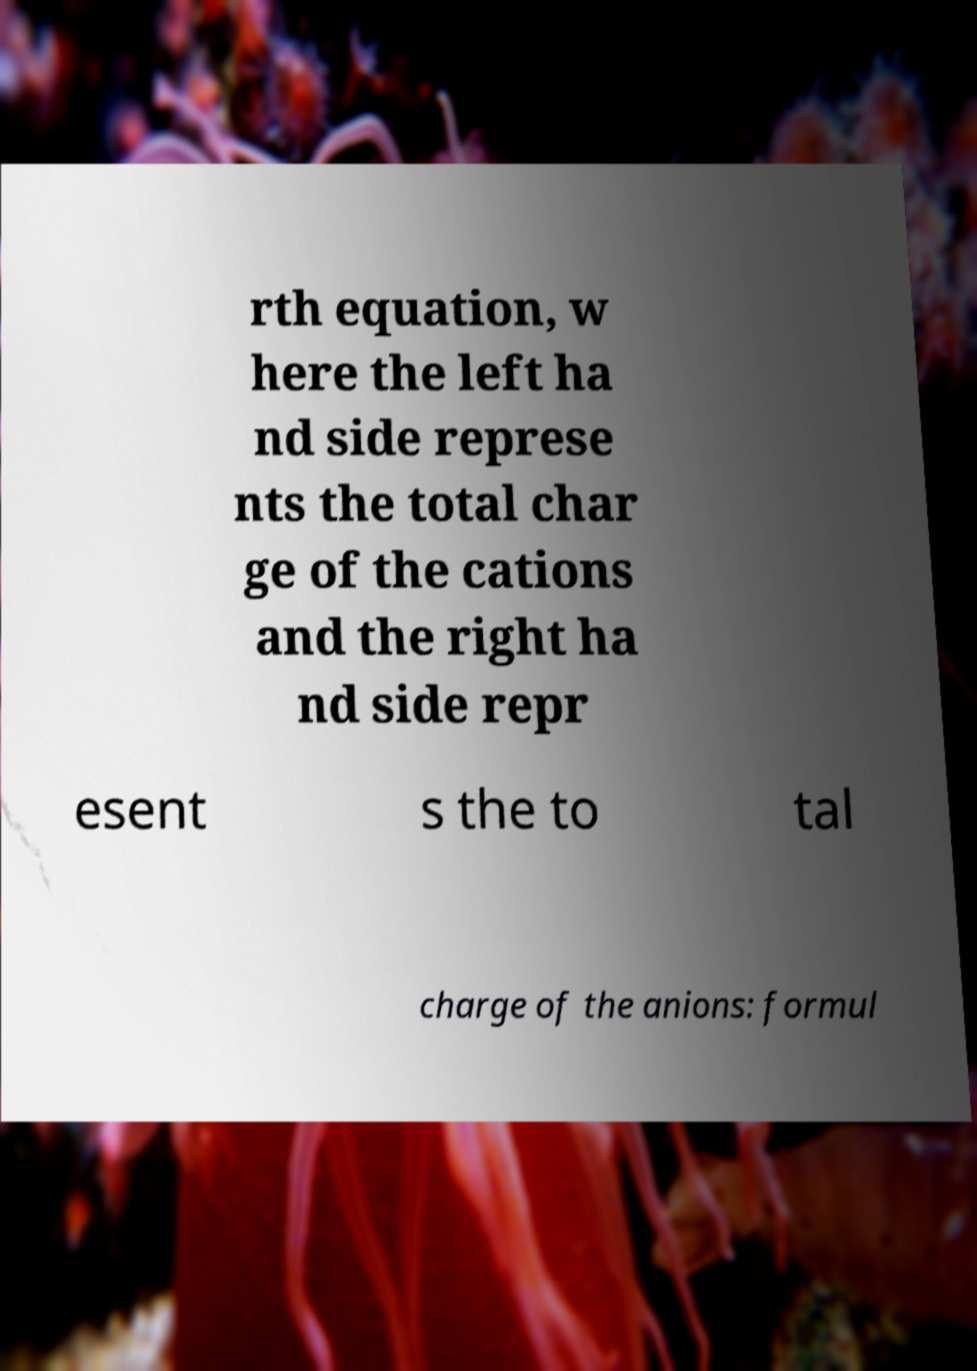Please read and relay the text visible in this image. What does it say? rth equation, w here the left ha nd side represe nts the total char ge of the cations and the right ha nd side repr esent s the to tal charge of the anions: formul 